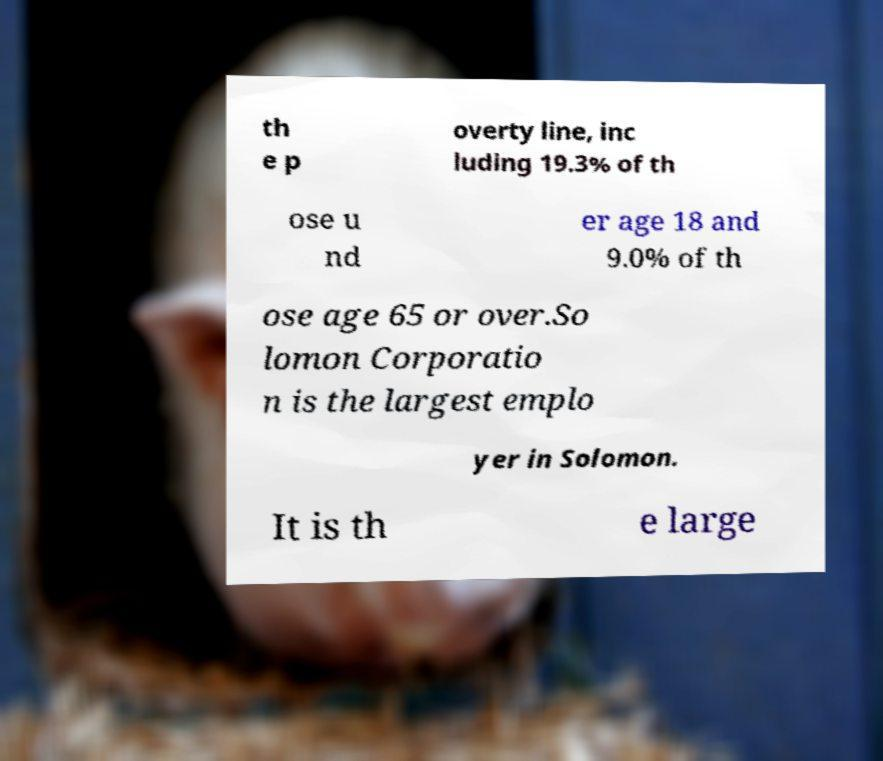Please identify and transcribe the text found in this image. th e p overty line, inc luding 19.3% of th ose u nd er age 18 and 9.0% of th ose age 65 or over.So lomon Corporatio n is the largest emplo yer in Solomon. It is th e large 